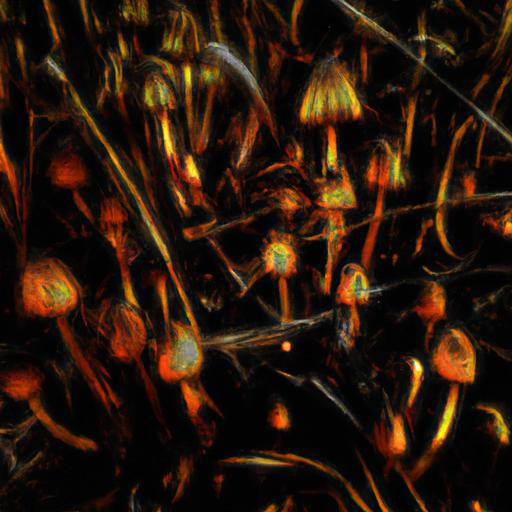How might this image make the viewer feel? The combination of warm colors, darkness, and glowing elements might evoke a sense of warmth, intrigue, and contemplation. The abstract nature allows viewers to impart their own emotions and interpretations, which could range from awe to a serene, dream-like curiosity. 